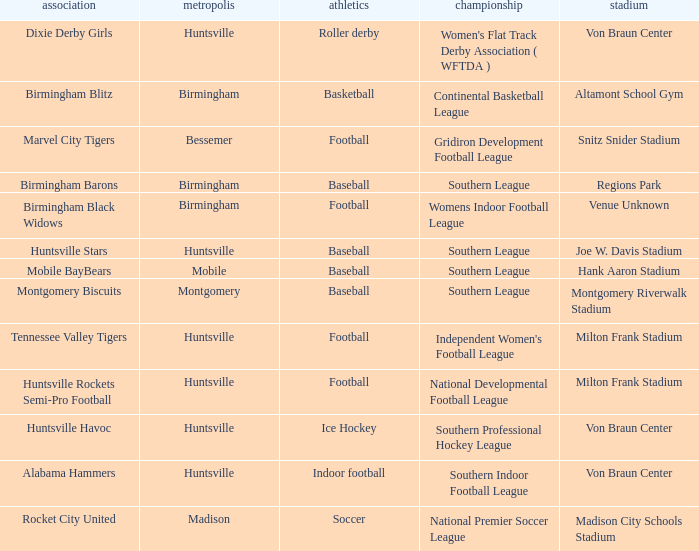Which venue held a basketball team? Altamont School Gym. 